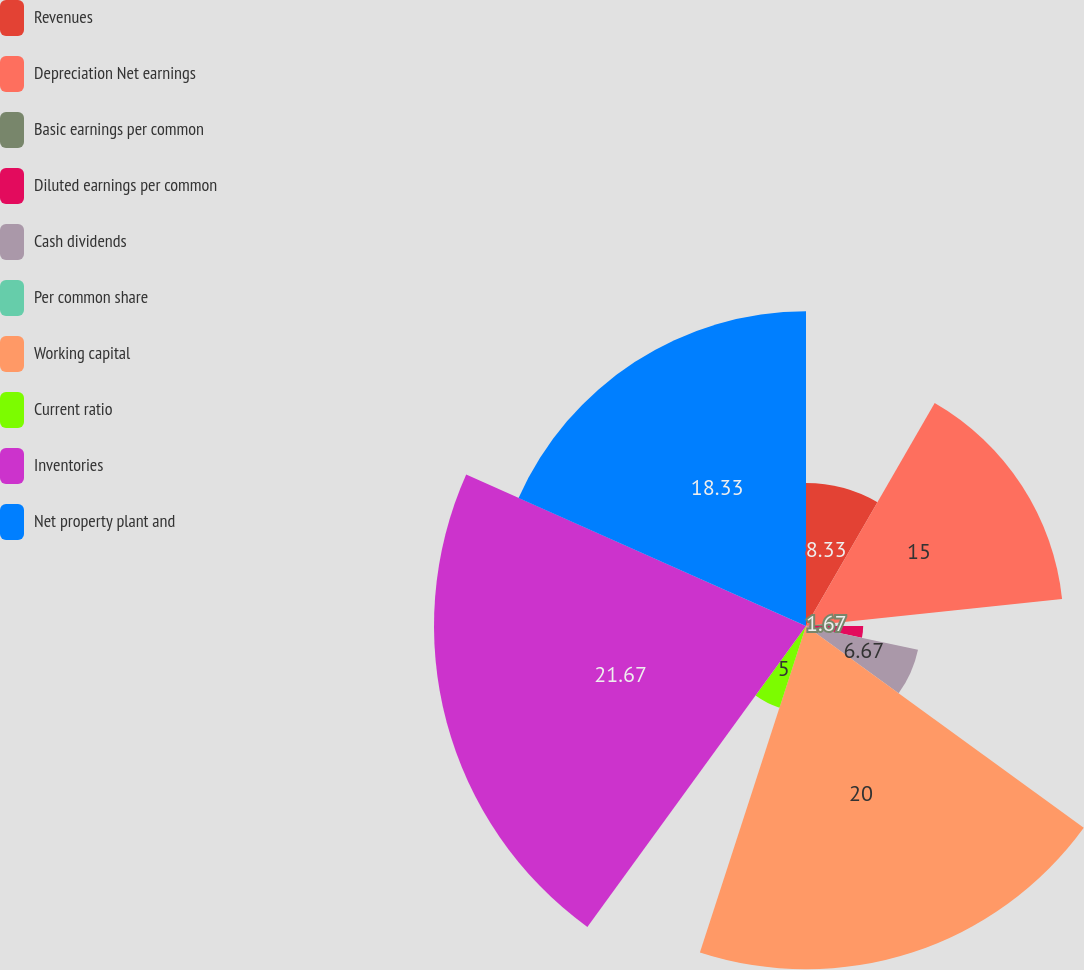Convert chart. <chart><loc_0><loc_0><loc_500><loc_500><pie_chart><fcel>Revenues<fcel>Depreciation Net earnings<fcel>Basic earnings per common<fcel>Diluted earnings per common<fcel>Cash dividends<fcel>Per common share<fcel>Working capital<fcel>Current ratio<fcel>Inventories<fcel>Net property plant and<nl><fcel>8.33%<fcel>15.0%<fcel>1.67%<fcel>3.33%<fcel>6.67%<fcel>0.0%<fcel>20.0%<fcel>5.0%<fcel>21.67%<fcel>18.33%<nl></chart> 